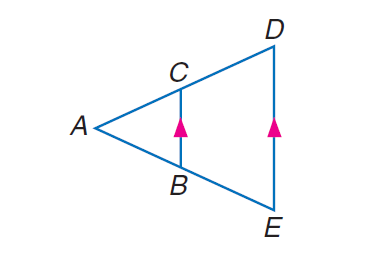Answer the mathemtical geometry problem and directly provide the correct option letter.
Question: Find x if A C = x - 3, B E = 20, A B = 16, and C D = x + 5.
Choices: A: 21 B: 35 C: 36 D: 46 B 